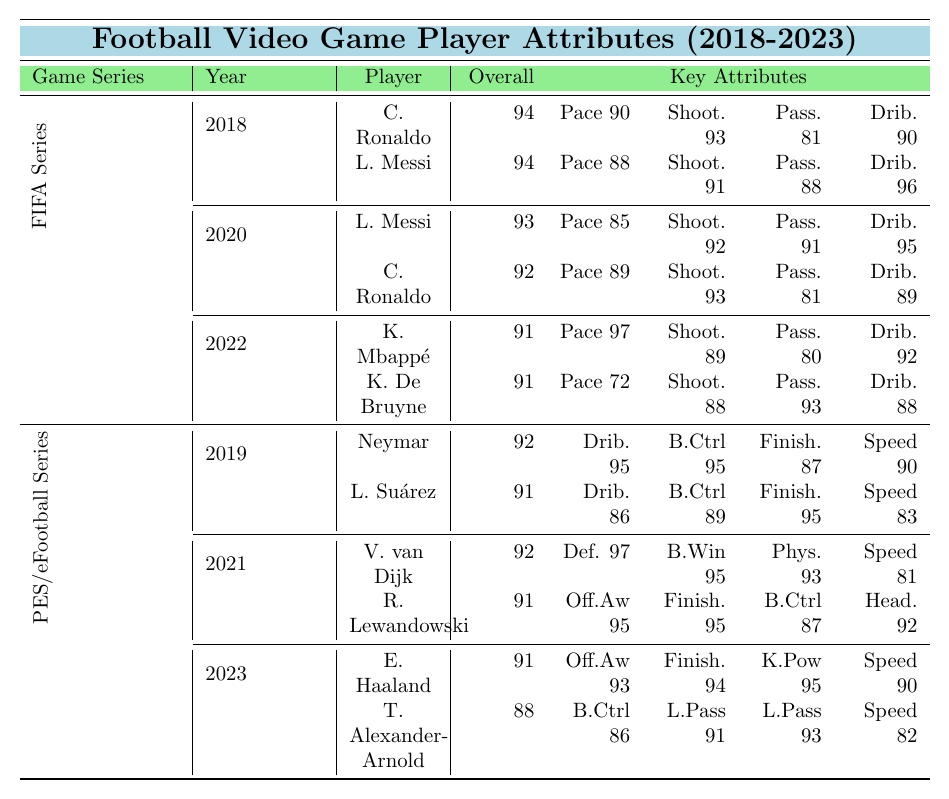What is the overall rating of Cristiano Ronaldo in FIFA 19? In the FIFA Series section under the year 2018, Cristiano Ronaldo's overall rating is mentioned as 94.
Answer: 94 What is the pace rating of Kylian Mbappé in FIFA 23? In the FIFA Series section under the year 2022, Kylian Mbappé's pace rating is given as 97.
Answer: 97 Which player has the highest overall rating in PES 2019? In the PES/eFootball Series section under the year 2019, Neymar has an overall rating of 92, and Luis Suárez has an overall rating of 91. Neymar has the highest rating.
Answer: Neymar Which player has better dribbling: Lionel Messi in FIFA 21 or Neymar in PES 2019? In FIFA 21, Messi's dribbling rating is 95, while in PES 2019, Neymar's dribbling rating is 95 as well; they are equal.
Answer: Equal What is the average overall rating of the top players in FIFA 21? In FIFA 21, the top players are Lionel Messi (93) and Cristiano Ronaldo (92). The average is (93 + 92) / 2 = 92.5.
Answer: 92.5 Which player has the best shooting attribute in the FIFA Series across the years provided? Analyzing the shooting attributes, Cristiano Ronaldo in FIFA 19 has a rating of 93, Lionel Messi in FIFA 21 has a shooting rating of 92, Kylian Mbappé in FIFA 23 has 89, and Kevin De Bruyne has 88. Thus, Cristiano Ronaldo in FIFA 19 has the highest shooting rating.
Answer: Cristiano Ronaldo in FIFA 19 What is the difference in overall rating between Lionel Messi in FIFA 19 and FIFA 21? Lionel Messi has an overall rating of 94 in FIFA 19 and 93 in FIFA 21. The difference is 94 - 93 = 1.
Answer: 1 Is it true that Erling Haaland has a higher overall rating than Neymar in any instance? Erling Haaland has an overall rating of 91 in eFootball 2023 while Neymar has 92 in PES 2019, meaning Haaland does not have a higher rating than Neymar.
Answer: No Which game allows you to play with the highest defending prowess as rated? In eFootball PES 2021, Virgil van Dijk has a defensive prowess rating of 97, which is the highest compared to other games listed.
Answer: eFootball PES 2021 What percentage of players in the FIFA Series have an overall rating of 91 or higher? There are 6 players in total in the FIFA Series, and 4 players (Cristiano Ronaldo, Lionel Messi, Kylian Mbappé, Kevin De Bruyne) have ratings of 91 or higher. The percentage is (4/6) * 100 = 66.67%.
Answer: 66.67% What is the overall rating of Trent Alexander-Arnold compared to the top-rated players in FIFA 23? In FIFA 23, both Kylian Mbappé and Kevin De Bruyne have an overall rating of 91. Trent Alexander-Arnold's rating is 88, which is lower than both top-rated players.
Answer: Lower than both 